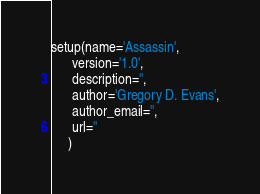<code> <loc_0><loc_0><loc_500><loc_500><_Python_>
setup(name='Assassin',
      version='1.0',
      description='',
      author='Gregory D. Evans',
      author_email='',
      url=''
     )</code> 